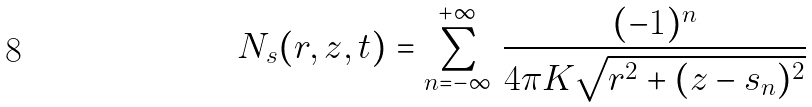<formula> <loc_0><loc_0><loc_500><loc_500>N _ { s } ( r , z , t ) = \sum _ { n = - \infty } ^ { + \infty } \, \frac { ( - 1 ) ^ { n } } { 4 \pi K \sqrt { r ^ { 2 } + ( z - s _ { n } ) ^ { 2 } } }</formula> 